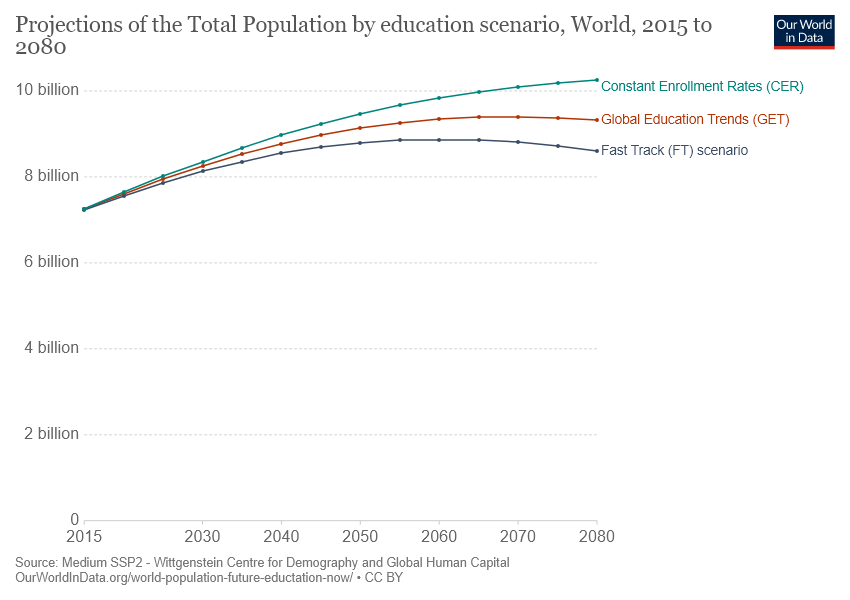Give some essential details in this illustration. The gap between the three lines reaches its smallest point in 2015. The green line in the graph refers to constant enrollment rates (CER). 